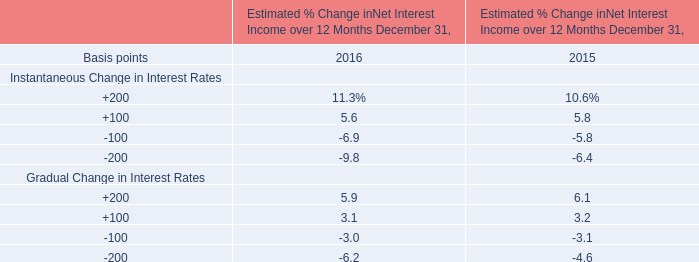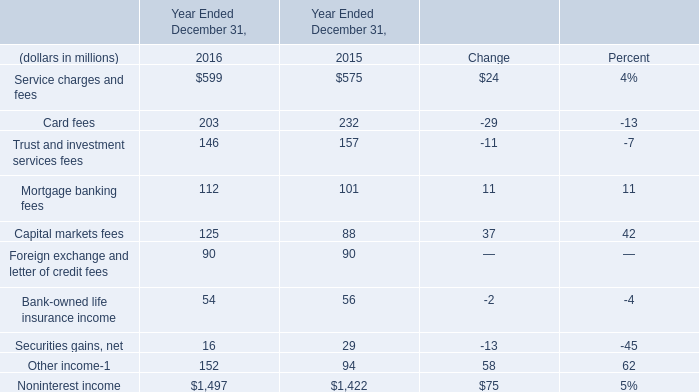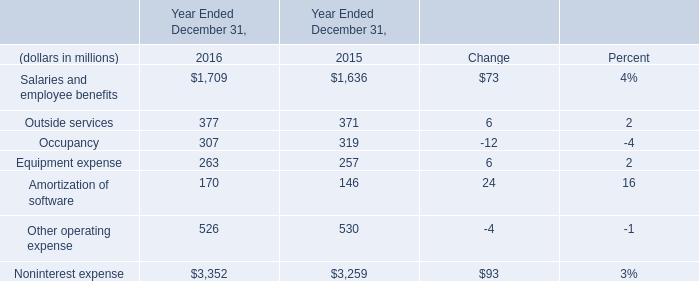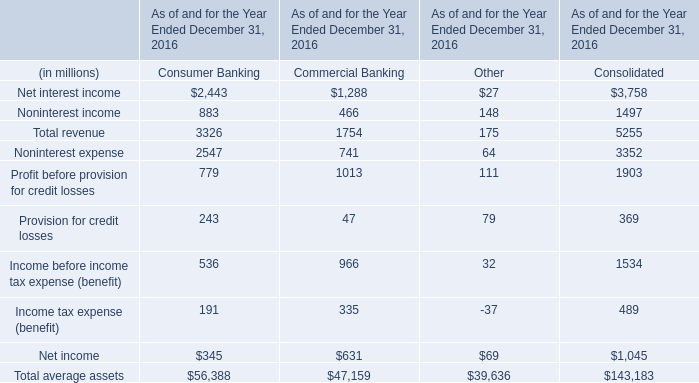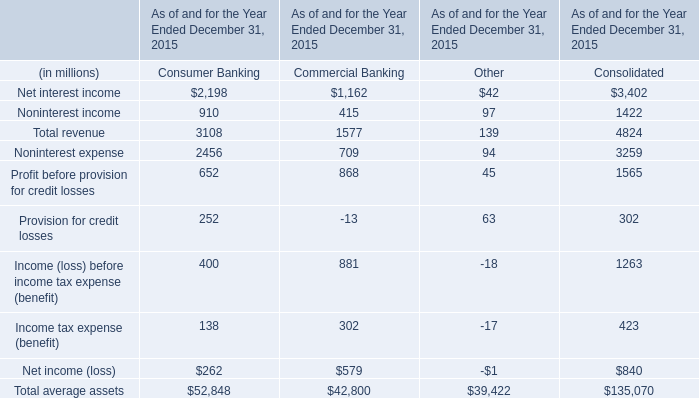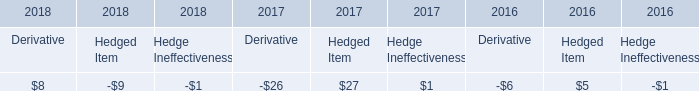In which year the Salaries and employee benefits is positive? 
Answer: 2016. 